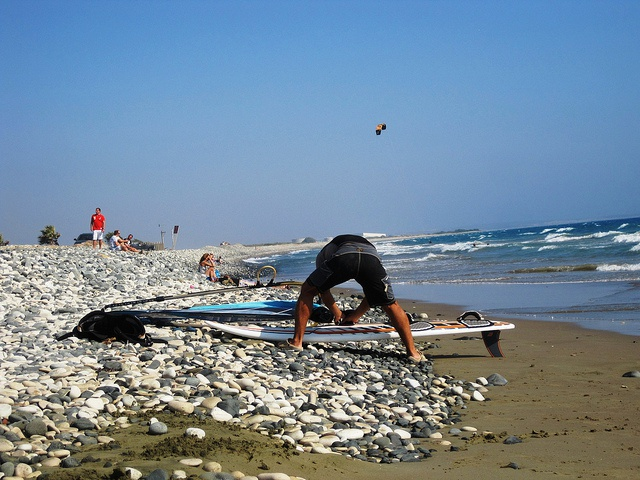Describe the objects in this image and their specific colors. I can see people in gray, black, maroon, and darkgray tones, surfboard in gray, black, white, and darkgray tones, backpack in gray, black, maroon, and darkgray tones, surfboard in gray, black, navy, and lightblue tones, and people in gray, red, darkgray, white, and brown tones in this image. 